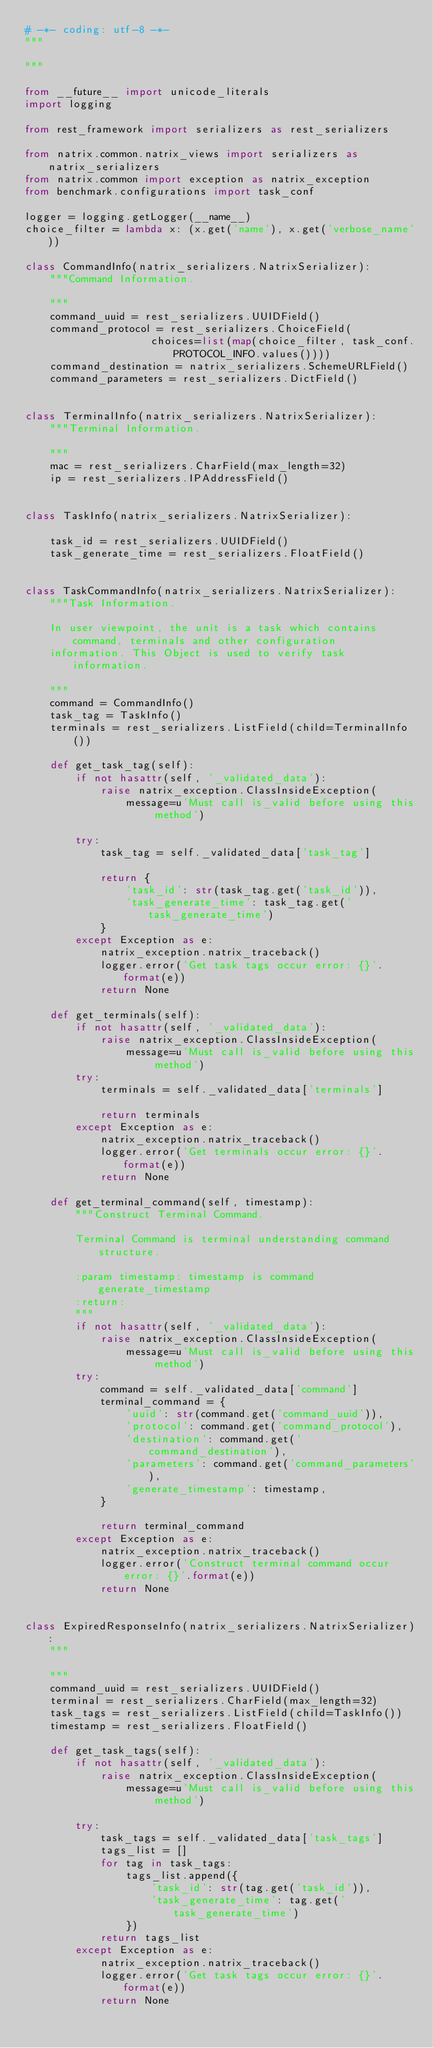Convert code to text. <code><loc_0><loc_0><loc_500><loc_500><_Python_># -*- coding: utf-8 -*-
"""

"""

from __future__ import unicode_literals
import logging

from rest_framework import serializers as rest_serializers

from natrix.common.natrix_views import serializers as natrix_serializers
from natrix.common import exception as natrix_exception
from benchmark.configurations import task_conf

logger = logging.getLogger(__name__)
choice_filter = lambda x: (x.get('name'), x.get('verbose_name'))

class CommandInfo(natrix_serializers.NatrixSerializer):
    """Command Information.

    """
    command_uuid = rest_serializers.UUIDField()
    command_protocol = rest_serializers.ChoiceField(
                    choices=list(map(choice_filter, task_conf.PROTOCOL_INFO.values())))
    command_destination = natrix_serializers.SchemeURLField()
    command_parameters = rest_serializers.DictField()


class TerminalInfo(natrix_serializers.NatrixSerializer):
    """Terminal Information.

    """
    mac = rest_serializers.CharField(max_length=32)
    ip = rest_serializers.IPAddressField()


class TaskInfo(natrix_serializers.NatrixSerializer):

    task_id = rest_serializers.UUIDField()
    task_generate_time = rest_serializers.FloatField()


class TaskCommandInfo(natrix_serializers.NatrixSerializer):
    """Task Information.

    In user viewpoint, the unit is a task which contains command, terminals and other configuration
    information. This Object is used to verify task information.

    """
    command = CommandInfo()
    task_tag = TaskInfo()
    terminals = rest_serializers.ListField(child=TerminalInfo())

    def get_task_tag(self):
        if not hasattr(self, '_validated_data'):
            raise natrix_exception.ClassInsideException(
                message=u'Must call is_valid before using this method')

        try:
            task_tag = self._validated_data['task_tag']

            return {
                'task_id': str(task_tag.get('task_id')),
                'task_generate_time': task_tag.get('task_generate_time')
            }
        except Exception as e:
            natrix_exception.natrix_traceback()
            logger.error('Get task tags occur error: {}'.format(e))
            return None

    def get_terminals(self):
        if not hasattr(self, '_validated_data'):
            raise natrix_exception.ClassInsideException(
                message=u'Must call is_valid before using this method')
        try:
            terminals = self._validated_data['terminals']

            return terminals
        except Exception as e:
            natrix_exception.natrix_traceback()
            logger.error('Get terminals occur error: {}'.format(e))
            return None

    def get_terminal_command(self, timestamp):
        """Construct Terminal Command.

        Terminal Command is terminal understanding command structure.

        :param timestamp: timestamp is command generate_timestamp
        :return:
        """
        if not hasattr(self, '_validated_data'):
            raise natrix_exception.ClassInsideException(
                message=u'Must call is_valid before using this method')
        try:
            command = self._validated_data['command']
            terminal_command = {
                'uuid': str(command.get('command_uuid')),
                'protocol': command.get('command_protocol'),
                'destination': command.get('command_destination'),
                'parameters': command.get('command_parameters'),
                'generate_timestamp': timestamp,
            }

            return terminal_command
        except Exception as e:
            natrix_exception.natrix_traceback()
            logger.error('Construct terminal command occur error: {}'.format(e))
            return None


class ExpiredResponseInfo(natrix_serializers.NatrixSerializer):
    """

    """
    command_uuid = rest_serializers.UUIDField()
    terminal = rest_serializers.CharField(max_length=32)
    task_tags = rest_serializers.ListField(child=TaskInfo())
    timestamp = rest_serializers.FloatField()

    def get_task_tags(self):
        if not hasattr(self, '_validated_data'):
            raise natrix_exception.ClassInsideException(
                message=u'Must call is_valid before using this method')

        try:
            task_tags = self._validated_data['task_tags']
            tags_list = []
            for tag in task_tags:
                tags_list.append({
                    'task_id': str(tag.get('task_id')),
                    'task_generate_time': tag.get('task_generate_time')
                })
            return tags_list
        except Exception as e:
            natrix_exception.natrix_traceback()
            logger.error('Get task tags occur error: {}'.format(e))
            return None







</code> 